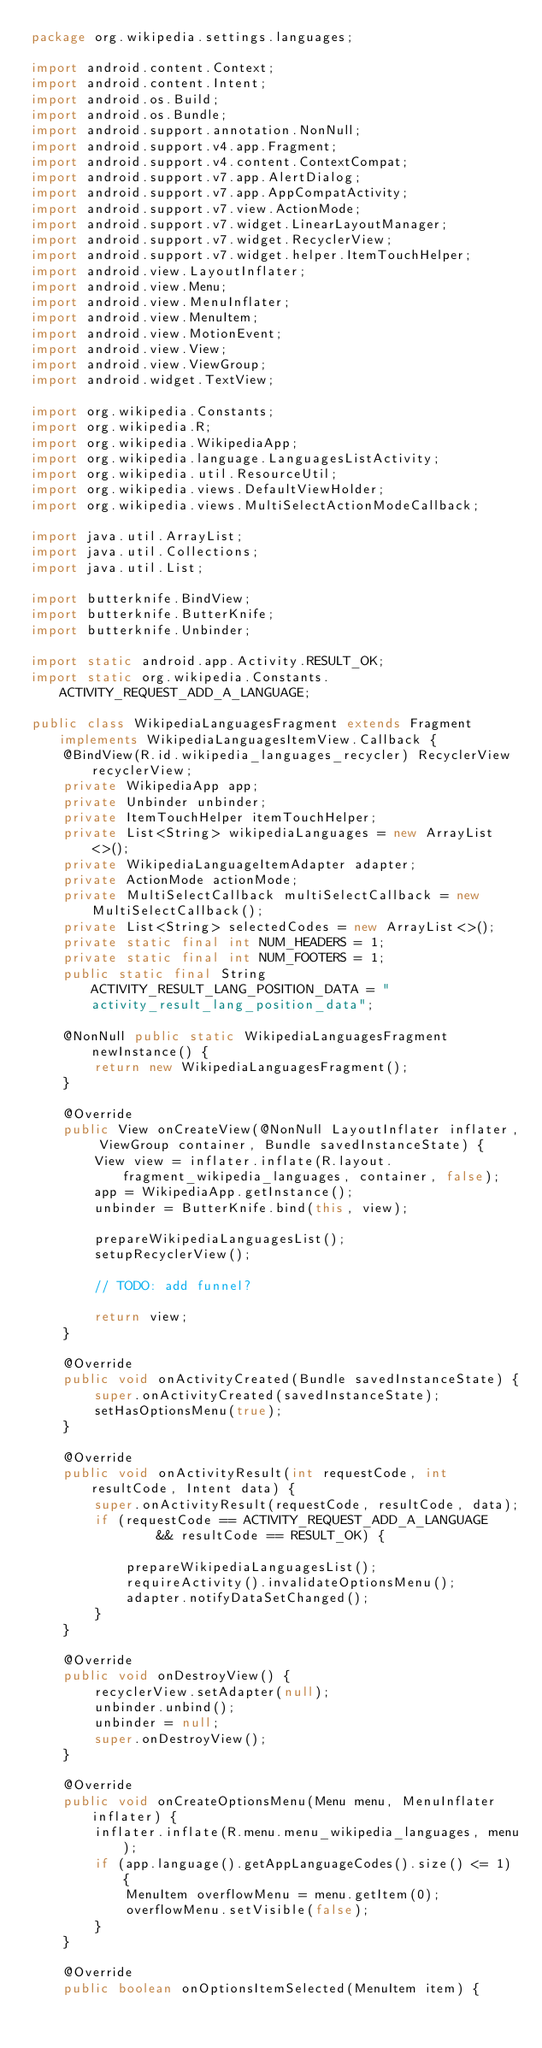<code> <loc_0><loc_0><loc_500><loc_500><_Java_>package org.wikipedia.settings.languages;

import android.content.Context;
import android.content.Intent;
import android.os.Build;
import android.os.Bundle;
import android.support.annotation.NonNull;
import android.support.v4.app.Fragment;
import android.support.v4.content.ContextCompat;
import android.support.v7.app.AlertDialog;
import android.support.v7.app.AppCompatActivity;
import android.support.v7.view.ActionMode;
import android.support.v7.widget.LinearLayoutManager;
import android.support.v7.widget.RecyclerView;
import android.support.v7.widget.helper.ItemTouchHelper;
import android.view.LayoutInflater;
import android.view.Menu;
import android.view.MenuInflater;
import android.view.MenuItem;
import android.view.MotionEvent;
import android.view.View;
import android.view.ViewGroup;
import android.widget.TextView;

import org.wikipedia.Constants;
import org.wikipedia.R;
import org.wikipedia.WikipediaApp;
import org.wikipedia.language.LanguagesListActivity;
import org.wikipedia.util.ResourceUtil;
import org.wikipedia.views.DefaultViewHolder;
import org.wikipedia.views.MultiSelectActionModeCallback;

import java.util.ArrayList;
import java.util.Collections;
import java.util.List;

import butterknife.BindView;
import butterknife.ButterKnife;
import butterknife.Unbinder;

import static android.app.Activity.RESULT_OK;
import static org.wikipedia.Constants.ACTIVITY_REQUEST_ADD_A_LANGUAGE;

public class WikipediaLanguagesFragment extends Fragment implements WikipediaLanguagesItemView.Callback {
    @BindView(R.id.wikipedia_languages_recycler) RecyclerView recyclerView;
    private WikipediaApp app;
    private Unbinder unbinder;
    private ItemTouchHelper itemTouchHelper;
    private List<String> wikipediaLanguages = new ArrayList<>();
    private WikipediaLanguageItemAdapter adapter;
    private ActionMode actionMode;
    private MultiSelectCallback multiSelectCallback = new MultiSelectCallback();
    private List<String> selectedCodes = new ArrayList<>();
    private static final int NUM_HEADERS = 1;
    private static final int NUM_FOOTERS = 1;
    public static final String ACTIVITY_RESULT_LANG_POSITION_DATA = "activity_result_lang_position_data";

    @NonNull public static WikipediaLanguagesFragment newInstance() {
        return new WikipediaLanguagesFragment();
    }

    @Override
    public View onCreateView(@NonNull LayoutInflater inflater, ViewGroup container, Bundle savedInstanceState) {
        View view = inflater.inflate(R.layout.fragment_wikipedia_languages, container, false);
        app = WikipediaApp.getInstance();
        unbinder = ButterKnife.bind(this, view);

        prepareWikipediaLanguagesList();
        setupRecyclerView();

        // TODO: add funnel?

        return view;
    }

    @Override
    public void onActivityCreated(Bundle savedInstanceState) {
        super.onActivityCreated(savedInstanceState);
        setHasOptionsMenu(true);
    }

    @Override
    public void onActivityResult(int requestCode, int resultCode, Intent data) {
        super.onActivityResult(requestCode, resultCode, data);
        if (requestCode == ACTIVITY_REQUEST_ADD_A_LANGUAGE
                && resultCode == RESULT_OK) {

            prepareWikipediaLanguagesList();
            requireActivity().invalidateOptionsMenu();
            adapter.notifyDataSetChanged();
        }
    }

    @Override
    public void onDestroyView() {
        recyclerView.setAdapter(null);
        unbinder.unbind();
        unbinder = null;
        super.onDestroyView();
    }

    @Override
    public void onCreateOptionsMenu(Menu menu, MenuInflater inflater) {
        inflater.inflate(R.menu.menu_wikipedia_languages, menu);
        if (app.language().getAppLanguageCodes().size() <= 1) {
            MenuItem overflowMenu = menu.getItem(0);
            overflowMenu.setVisible(false);
        }
    }

    @Override
    public boolean onOptionsItemSelected(MenuItem item) {</code> 